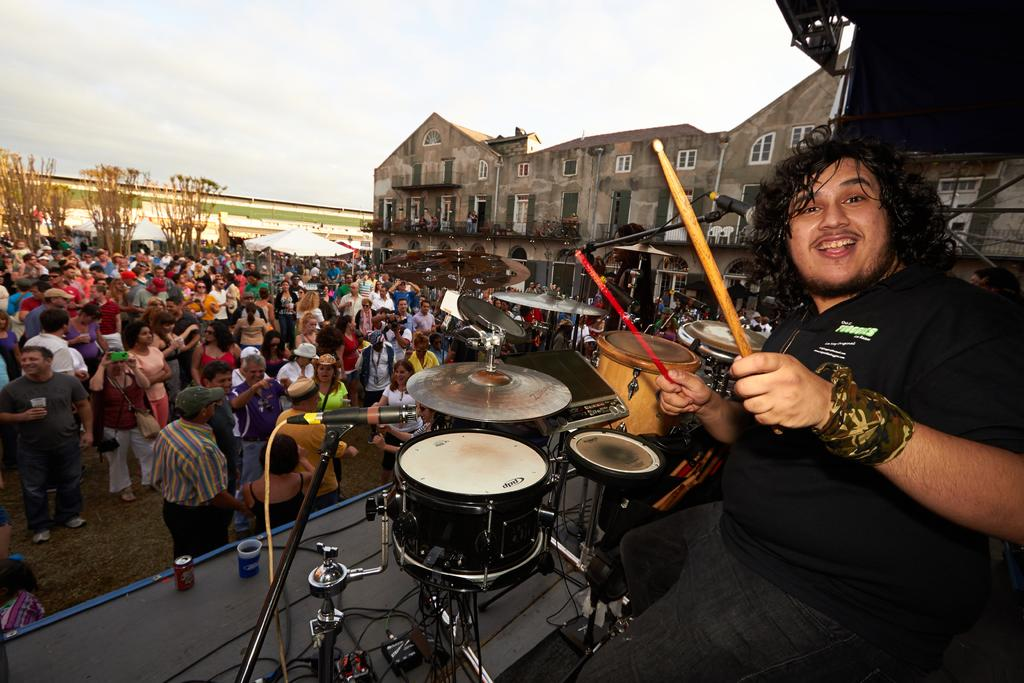What is the person in the image wearing? The person is wearing a black dress in the image. What is the person holding in their hands? The person is holding drum sticks in the image. What musical instruments are present in the image? There are drums in the image. What device is used for amplifying the person's voice? There is a microphone (mic) in the image. Who is the person performing for in the image? There is an audience in front of the person in the image. What type of observation did the person make about their account before attempting to play the drums? There is no information about any observations or accounts in the image; the person is simply holding drum sticks and there are drums present. 